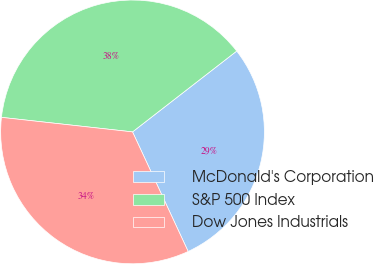<chart> <loc_0><loc_0><loc_500><loc_500><pie_chart><fcel>McDonald's Corporation<fcel>S&P 500 Index<fcel>Dow Jones Industrials<nl><fcel>28.57%<fcel>37.74%<fcel>33.69%<nl></chart> 